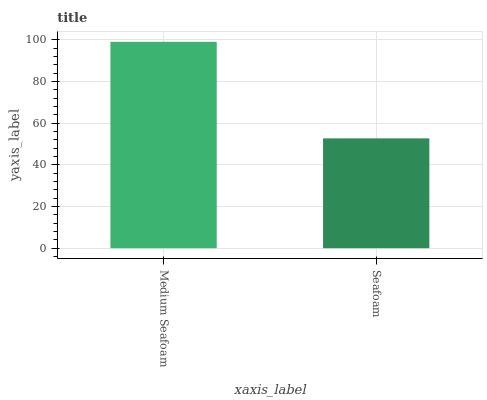Is Seafoam the minimum?
Answer yes or no. Yes. Is Medium Seafoam the maximum?
Answer yes or no. Yes. Is Seafoam the maximum?
Answer yes or no. No. Is Medium Seafoam greater than Seafoam?
Answer yes or no. Yes. Is Seafoam less than Medium Seafoam?
Answer yes or no. Yes. Is Seafoam greater than Medium Seafoam?
Answer yes or no. No. Is Medium Seafoam less than Seafoam?
Answer yes or no. No. Is Medium Seafoam the high median?
Answer yes or no. Yes. Is Seafoam the low median?
Answer yes or no. Yes. Is Seafoam the high median?
Answer yes or no. No. Is Medium Seafoam the low median?
Answer yes or no. No. 